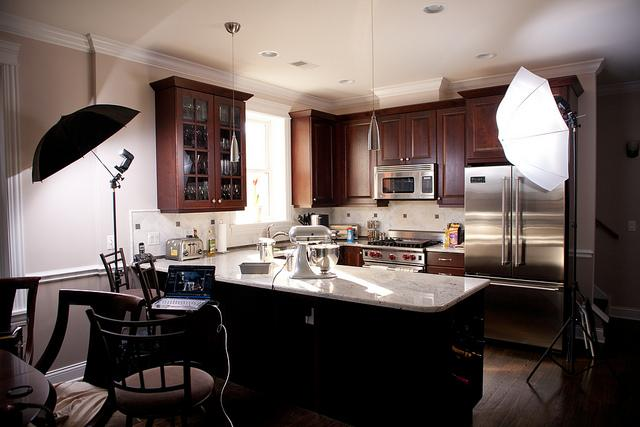What are the umbrellas being used for?

Choices:
A) lighting
B) blocking sun
C) stopping rain
D) decoration lighting 